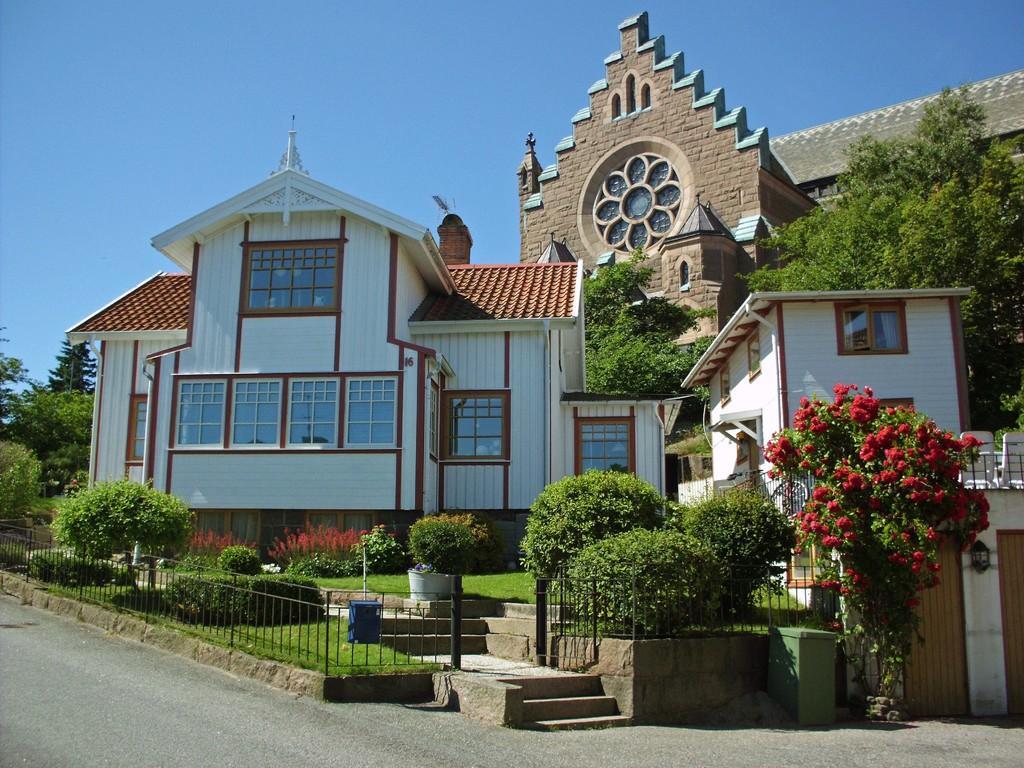How would you summarize this image in a sentence or two? In this image I can see the road, the railing, few stairs, some grass, few plants and few flowers which are red in color. I can see few buildings, few trees and the sky in the background. 